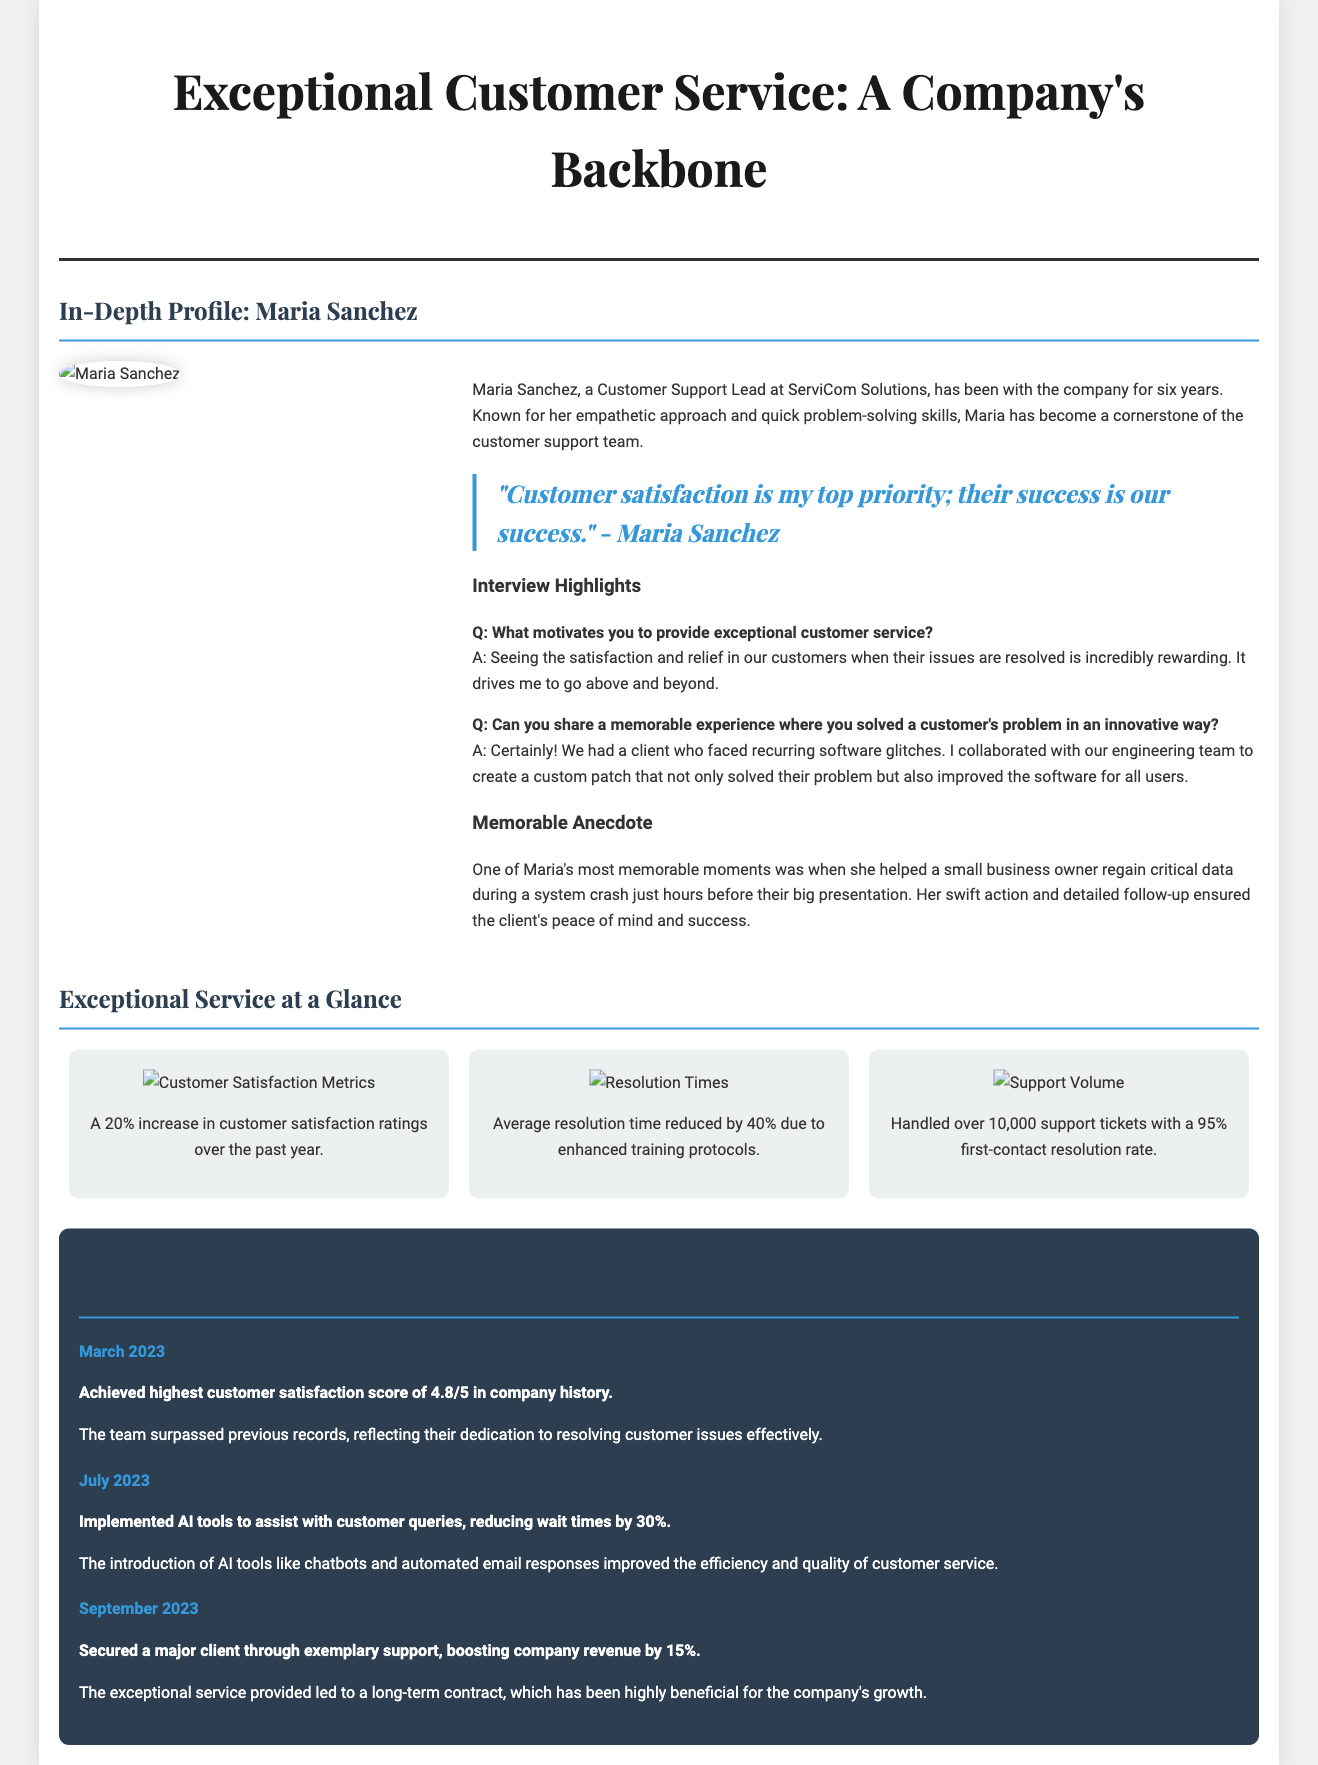What is the name of the featured customer support representative? The name of the featured representative is located in the profile section of the document.
Answer: Maria Sanchez How many years has Maria Sanchez worked at ServiCom Solutions? The document states her tenure with the company in the profile section.
Answer: Six years What is Maria Sanchez's title at the company? Her title is mentioned in the introductory paragraph of her profile.
Answer: Customer Support Lead What was the customer satisfaction score achieved in March 2023? The milestones section provides the specific score achieved by the team.
Answer: 4.8/5 By what percentage did customer satisfaction ratings increase over the past year? The infographics section highlights the percentage increase in customer satisfaction ratings.
Answer: 20% Which tools were implemented in July 2023 to assist with customer queries? The document specifies the types of tools introduced to improve efficiency in handling customer queries.
Answer: AI tools What was the average resolution time reduced by in the support department? The infographic section provides the specific percentage reduction achieved in resolution time.
Answer: 40% What is highlighted in Maria Sanchez's pull quote? The pull quote reflects her perspective on customer satisfaction as expressed in her profile.
Answer: "Customer satisfaction is my top priority; their success is our success." What significant achievement occurred in September 2023 related to client acquisition? The milestones section mentions a notable client acquisition and its impact on the company.
Answer: Secured a major client 